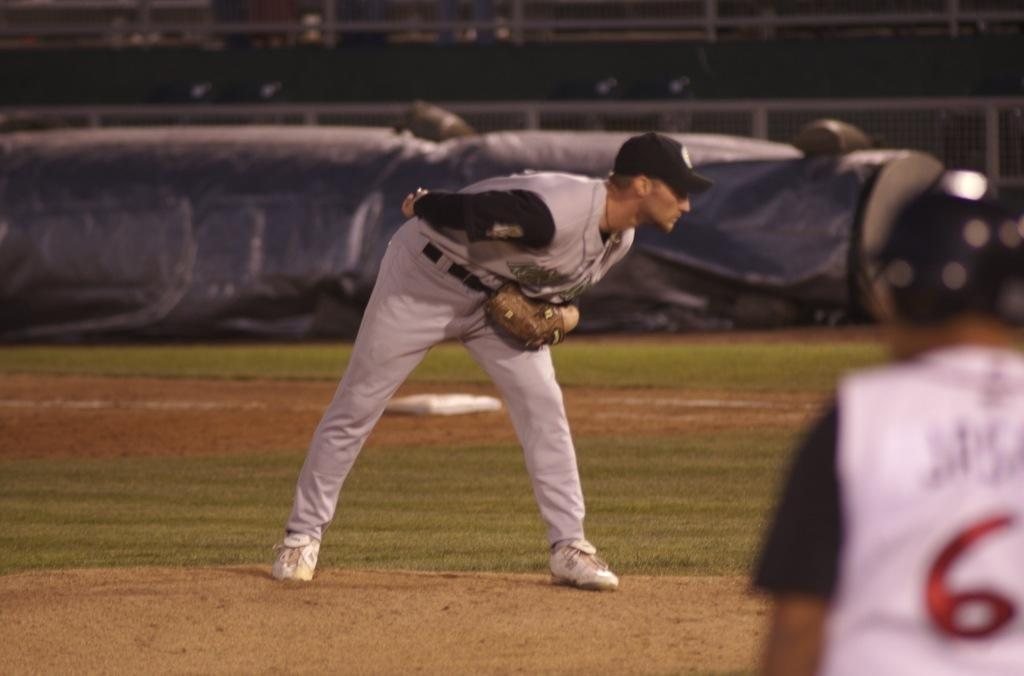<image>
Give a short and clear explanation of the subsequent image. A player whose number begins with 6 wears a batting helmet while the pitcher bends over. 